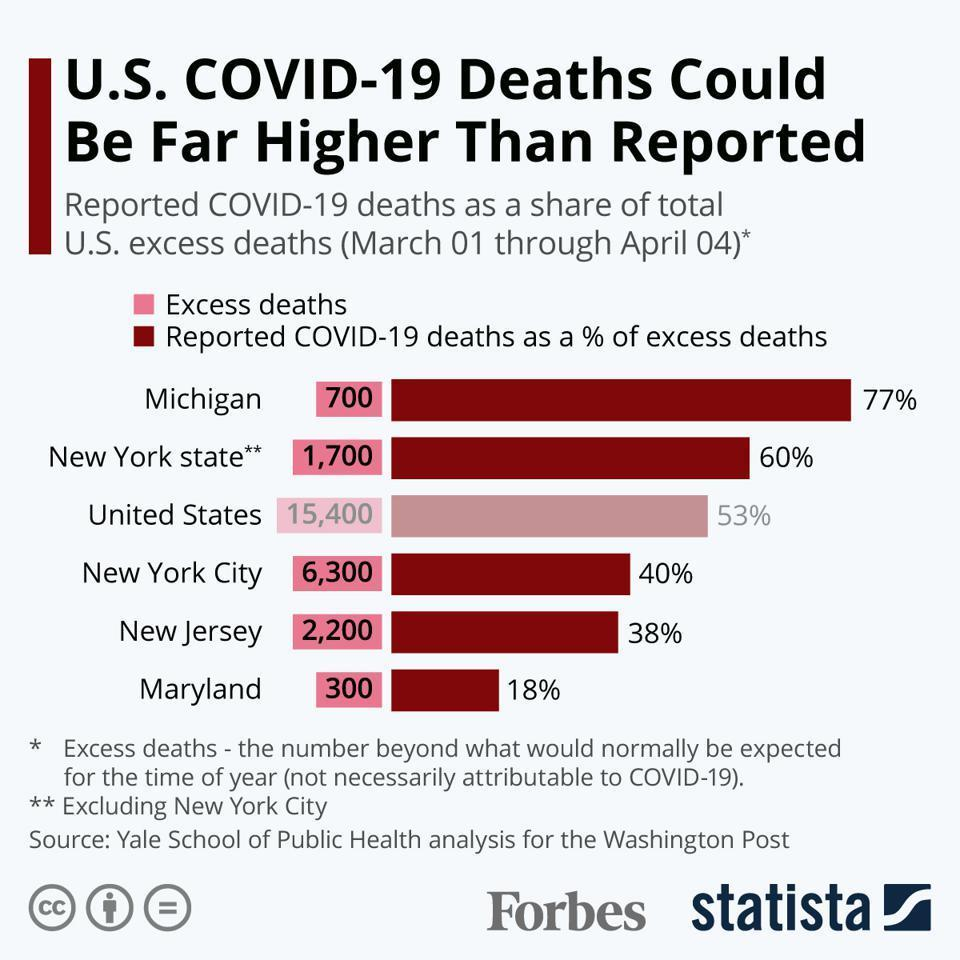In how many places is the percentage of reported COVID-19 deaths above 55%?
Answer the question with a short phrase. 2 Which of the places shown in the bar graph has the third lowest number of excess deaths? New York state In how many places shown in the bar graph is the number of excess deaths below 1000? 2 In which state is the percentage of reported COVID-19 deaths above 65%? Michigan In how many places shown in the bar graph is the percentage of reported COVID-19 deaths below 50%? 3 